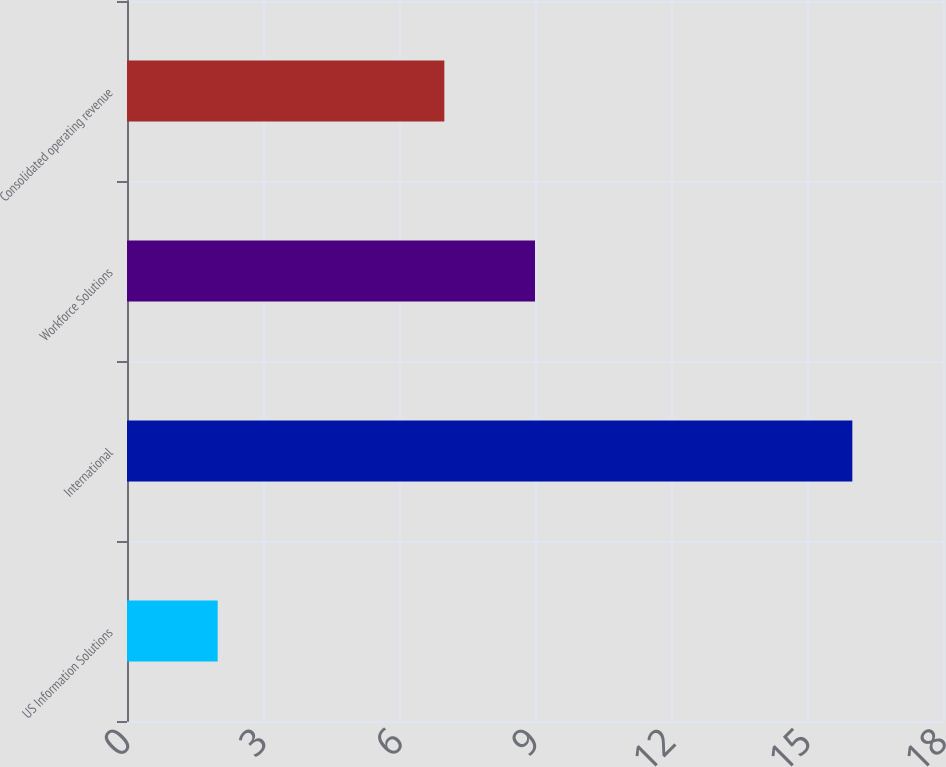<chart> <loc_0><loc_0><loc_500><loc_500><bar_chart><fcel>US Information Solutions<fcel>International<fcel>Workforce Solutions<fcel>Consolidated operating revenue<nl><fcel>2<fcel>16<fcel>9<fcel>7<nl></chart> 